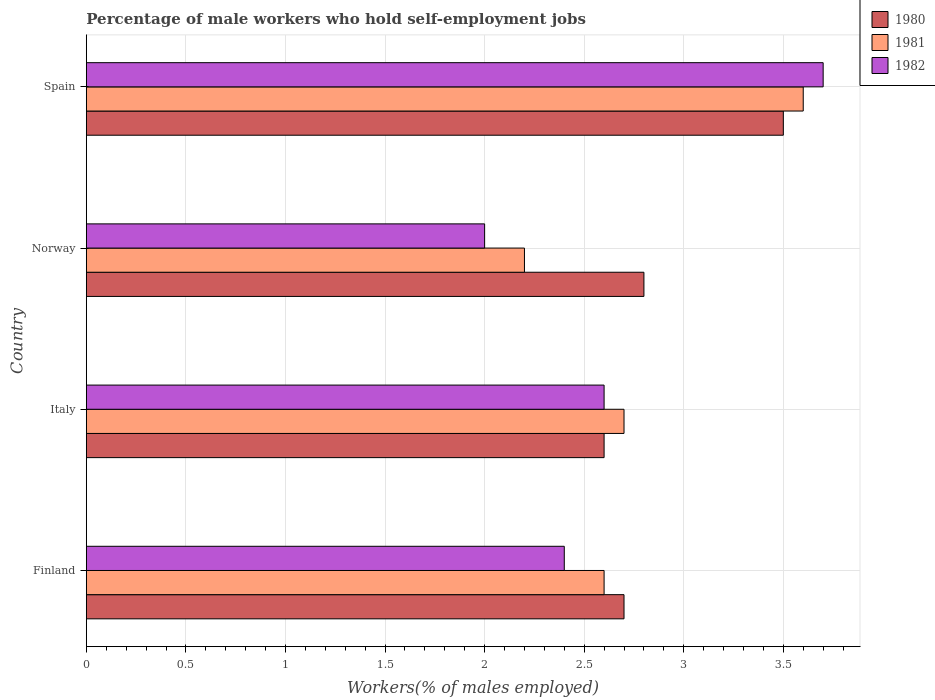How many bars are there on the 1st tick from the bottom?
Your response must be concise. 3. What is the label of the 4th group of bars from the top?
Provide a succinct answer. Finland. What is the percentage of self-employed male workers in 1981 in Finland?
Provide a short and direct response. 2.6. Across all countries, what is the maximum percentage of self-employed male workers in 1982?
Your answer should be compact. 3.7. What is the total percentage of self-employed male workers in 1981 in the graph?
Offer a very short reply. 11.1. What is the difference between the percentage of self-employed male workers in 1981 in Italy and that in Spain?
Ensure brevity in your answer.  -0.9. What is the difference between the percentage of self-employed male workers in 1982 in Italy and the percentage of self-employed male workers in 1980 in Finland?
Your answer should be very brief. -0.1. What is the average percentage of self-employed male workers in 1981 per country?
Provide a succinct answer. 2.77. What is the difference between the percentage of self-employed male workers in 1981 and percentage of self-employed male workers in 1982 in Finland?
Your answer should be very brief. 0.2. In how many countries, is the percentage of self-employed male workers in 1982 greater than 2.4 %?
Make the answer very short. 3. What is the ratio of the percentage of self-employed male workers in 1982 in Italy to that in Spain?
Provide a short and direct response. 0.7. What is the difference between the highest and the second highest percentage of self-employed male workers in 1981?
Your answer should be compact. 0.9. What is the difference between the highest and the lowest percentage of self-employed male workers in 1980?
Ensure brevity in your answer.  0.9. In how many countries, is the percentage of self-employed male workers in 1981 greater than the average percentage of self-employed male workers in 1981 taken over all countries?
Your answer should be very brief. 1. Is the sum of the percentage of self-employed male workers in 1980 in Finland and Spain greater than the maximum percentage of self-employed male workers in 1982 across all countries?
Your answer should be very brief. Yes. What does the 1st bar from the bottom in Norway represents?
Your answer should be compact. 1980. Is it the case that in every country, the sum of the percentage of self-employed male workers in 1982 and percentage of self-employed male workers in 1980 is greater than the percentage of self-employed male workers in 1981?
Provide a short and direct response. Yes. How many countries are there in the graph?
Keep it short and to the point. 4. What is the difference between two consecutive major ticks on the X-axis?
Provide a short and direct response. 0.5. Are the values on the major ticks of X-axis written in scientific E-notation?
Your answer should be very brief. No. How are the legend labels stacked?
Offer a very short reply. Vertical. What is the title of the graph?
Your answer should be compact. Percentage of male workers who hold self-employment jobs. What is the label or title of the X-axis?
Your response must be concise. Workers(% of males employed). What is the Workers(% of males employed) of 1980 in Finland?
Provide a succinct answer. 2.7. What is the Workers(% of males employed) of 1981 in Finland?
Give a very brief answer. 2.6. What is the Workers(% of males employed) in 1982 in Finland?
Provide a succinct answer. 2.4. What is the Workers(% of males employed) of 1980 in Italy?
Your answer should be very brief. 2.6. What is the Workers(% of males employed) in 1981 in Italy?
Provide a short and direct response. 2.7. What is the Workers(% of males employed) in 1982 in Italy?
Give a very brief answer. 2.6. What is the Workers(% of males employed) of 1980 in Norway?
Make the answer very short. 2.8. What is the Workers(% of males employed) in 1981 in Norway?
Offer a very short reply. 2.2. What is the Workers(% of males employed) of 1980 in Spain?
Offer a terse response. 3.5. What is the Workers(% of males employed) in 1981 in Spain?
Your response must be concise. 3.6. What is the Workers(% of males employed) of 1982 in Spain?
Offer a very short reply. 3.7. Across all countries, what is the maximum Workers(% of males employed) in 1981?
Make the answer very short. 3.6. Across all countries, what is the maximum Workers(% of males employed) in 1982?
Keep it short and to the point. 3.7. Across all countries, what is the minimum Workers(% of males employed) in 1980?
Give a very brief answer. 2.6. Across all countries, what is the minimum Workers(% of males employed) of 1981?
Provide a succinct answer. 2.2. Across all countries, what is the minimum Workers(% of males employed) in 1982?
Your answer should be very brief. 2. What is the total Workers(% of males employed) of 1982 in the graph?
Give a very brief answer. 10.7. What is the difference between the Workers(% of males employed) of 1982 in Finland and that in Italy?
Your answer should be very brief. -0.2. What is the difference between the Workers(% of males employed) in 1980 in Finland and that in Norway?
Give a very brief answer. -0.1. What is the difference between the Workers(% of males employed) of 1981 in Finland and that in Spain?
Ensure brevity in your answer.  -1. What is the difference between the Workers(% of males employed) of 1982 in Finland and that in Spain?
Your response must be concise. -1.3. What is the difference between the Workers(% of males employed) in 1980 in Italy and that in Norway?
Your answer should be very brief. -0.2. What is the difference between the Workers(% of males employed) in 1981 in Italy and that in Norway?
Your answer should be compact. 0.5. What is the difference between the Workers(% of males employed) in 1982 in Italy and that in Norway?
Offer a very short reply. 0.6. What is the difference between the Workers(% of males employed) in 1982 in Italy and that in Spain?
Give a very brief answer. -1.1. What is the difference between the Workers(% of males employed) in 1981 in Norway and that in Spain?
Give a very brief answer. -1.4. What is the difference between the Workers(% of males employed) in 1981 in Finland and the Workers(% of males employed) in 1982 in Italy?
Give a very brief answer. 0. What is the difference between the Workers(% of males employed) of 1980 in Finland and the Workers(% of males employed) of 1981 in Norway?
Your answer should be very brief. 0.5. What is the difference between the Workers(% of males employed) in 1981 in Finland and the Workers(% of males employed) in 1982 in Norway?
Your answer should be compact. 0.6. What is the difference between the Workers(% of males employed) in 1980 in Italy and the Workers(% of males employed) in 1981 in Norway?
Your answer should be very brief. 0.4. What is the difference between the Workers(% of males employed) in 1980 in Italy and the Workers(% of males employed) in 1982 in Norway?
Offer a very short reply. 0.6. What is the difference between the Workers(% of males employed) of 1981 in Italy and the Workers(% of males employed) of 1982 in Norway?
Offer a very short reply. 0.7. What is the difference between the Workers(% of males employed) in 1981 in Italy and the Workers(% of males employed) in 1982 in Spain?
Your response must be concise. -1. What is the difference between the Workers(% of males employed) of 1980 in Norway and the Workers(% of males employed) of 1982 in Spain?
Your response must be concise. -0.9. What is the average Workers(% of males employed) of 1980 per country?
Your answer should be compact. 2.9. What is the average Workers(% of males employed) in 1981 per country?
Provide a short and direct response. 2.77. What is the average Workers(% of males employed) of 1982 per country?
Your answer should be compact. 2.67. What is the difference between the Workers(% of males employed) in 1980 and Workers(% of males employed) in 1981 in Finland?
Offer a very short reply. 0.1. What is the difference between the Workers(% of males employed) in 1980 and Workers(% of males employed) in 1982 in Finland?
Give a very brief answer. 0.3. What is the difference between the Workers(% of males employed) of 1981 and Workers(% of males employed) of 1982 in Finland?
Your answer should be very brief. 0.2. What is the difference between the Workers(% of males employed) in 1980 and Workers(% of males employed) in 1981 in Italy?
Provide a succinct answer. -0.1. What is the difference between the Workers(% of males employed) in 1980 and Workers(% of males employed) in 1982 in Italy?
Give a very brief answer. 0. What is the difference between the Workers(% of males employed) in 1981 and Workers(% of males employed) in 1982 in Italy?
Your response must be concise. 0.1. What is the difference between the Workers(% of males employed) of 1980 and Workers(% of males employed) of 1981 in Norway?
Ensure brevity in your answer.  0.6. What is the difference between the Workers(% of males employed) of 1980 and Workers(% of males employed) of 1982 in Norway?
Your answer should be very brief. 0.8. What is the difference between the Workers(% of males employed) of 1981 and Workers(% of males employed) of 1982 in Norway?
Keep it short and to the point. 0.2. What is the difference between the Workers(% of males employed) of 1980 and Workers(% of males employed) of 1981 in Spain?
Give a very brief answer. -0.1. What is the difference between the Workers(% of males employed) in 1981 and Workers(% of males employed) in 1982 in Spain?
Offer a very short reply. -0.1. What is the ratio of the Workers(% of males employed) in 1980 in Finland to that in Italy?
Your answer should be very brief. 1.04. What is the ratio of the Workers(% of males employed) in 1982 in Finland to that in Italy?
Your response must be concise. 0.92. What is the ratio of the Workers(% of males employed) of 1981 in Finland to that in Norway?
Offer a terse response. 1.18. What is the ratio of the Workers(% of males employed) of 1980 in Finland to that in Spain?
Ensure brevity in your answer.  0.77. What is the ratio of the Workers(% of males employed) of 1981 in Finland to that in Spain?
Your answer should be compact. 0.72. What is the ratio of the Workers(% of males employed) of 1982 in Finland to that in Spain?
Your answer should be very brief. 0.65. What is the ratio of the Workers(% of males employed) of 1981 in Italy to that in Norway?
Offer a terse response. 1.23. What is the ratio of the Workers(% of males employed) in 1982 in Italy to that in Norway?
Offer a very short reply. 1.3. What is the ratio of the Workers(% of males employed) in 1980 in Italy to that in Spain?
Make the answer very short. 0.74. What is the ratio of the Workers(% of males employed) in 1982 in Italy to that in Spain?
Provide a succinct answer. 0.7. What is the ratio of the Workers(% of males employed) in 1980 in Norway to that in Spain?
Make the answer very short. 0.8. What is the ratio of the Workers(% of males employed) in 1981 in Norway to that in Spain?
Offer a terse response. 0.61. What is the ratio of the Workers(% of males employed) of 1982 in Norway to that in Spain?
Offer a very short reply. 0.54. What is the difference between the highest and the second highest Workers(% of males employed) of 1980?
Your response must be concise. 0.7. What is the difference between the highest and the second highest Workers(% of males employed) in 1981?
Provide a short and direct response. 0.9. What is the difference between the highest and the second highest Workers(% of males employed) of 1982?
Offer a very short reply. 1.1. What is the difference between the highest and the lowest Workers(% of males employed) in 1980?
Provide a succinct answer. 0.9. What is the difference between the highest and the lowest Workers(% of males employed) of 1982?
Offer a terse response. 1.7. 